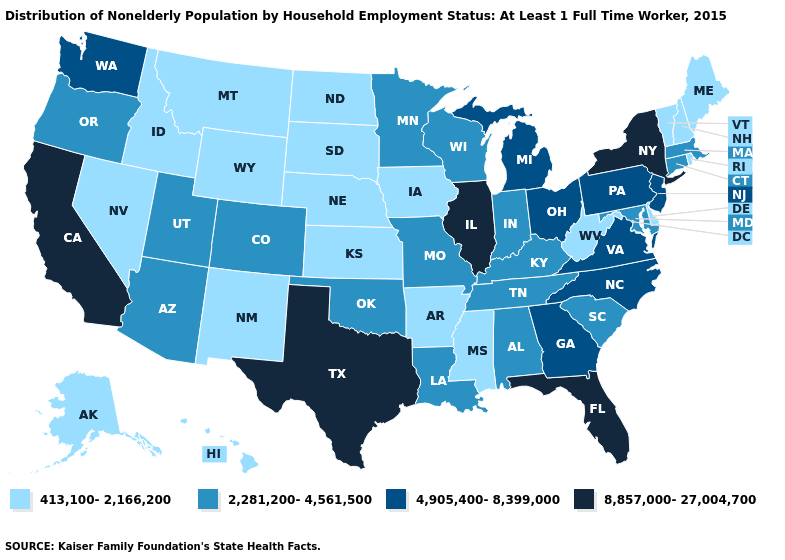Does the first symbol in the legend represent the smallest category?
Answer briefly. Yes. Among the states that border Pennsylvania , which have the highest value?
Concise answer only. New York. Which states have the highest value in the USA?
Answer briefly. California, Florida, Illinois, New York, Texas. What is the lowest value in states that border Colorado?
Keep it brief. 413,100-2,166,200. Does the first symbol in the legend represent the smallest category?
Keep it brief. Yes. What is the highest value in the USA?
Quick response, please. 8,857,000-27,004,700. Name the states that have a value in the range 8,857,000-27,004,700?
Short answer required. California, Florida, Illinois, New York, Texas. Which states have the highest value in the USA?
Quick response, please. California, Florida, Illinois, New York, Texas. Name the states that have a value in the range 2,281,200-4,561,500?
Quick response, please. Alabama, Arizona, Colorado, Connecticut, Indiana, Kentucky, Louisiana, Maryland, Massachusetts, Minnesota, Missouri, Oklahoma, Oregon, South Carolina, Tennessee, Utah, Wisconsin. Among the states that border Arkansas , does Oklahoma have the lowest value?
Give a very brief answer. No. Does Tennessee have the lowest value in the USA?
Give a very brief answer. No. What is the value of Utah?
Quick response, please. 2,281,200-4,561,500. Which states have the lowest value in the West?
Short answer required. Alaska, Hawaii, Idaho, Montana, Nevada, New Mexico, Wyoming. Name the states that have a value in the range 8,857,000-27,004,700?
Answer briefly. California, Florida, Illinois, New York, Texas. Name the states that have a value in the range 8,857,000-27,004,700?
Quick response, please. California, Florida, Illinois, New York, Texas. 